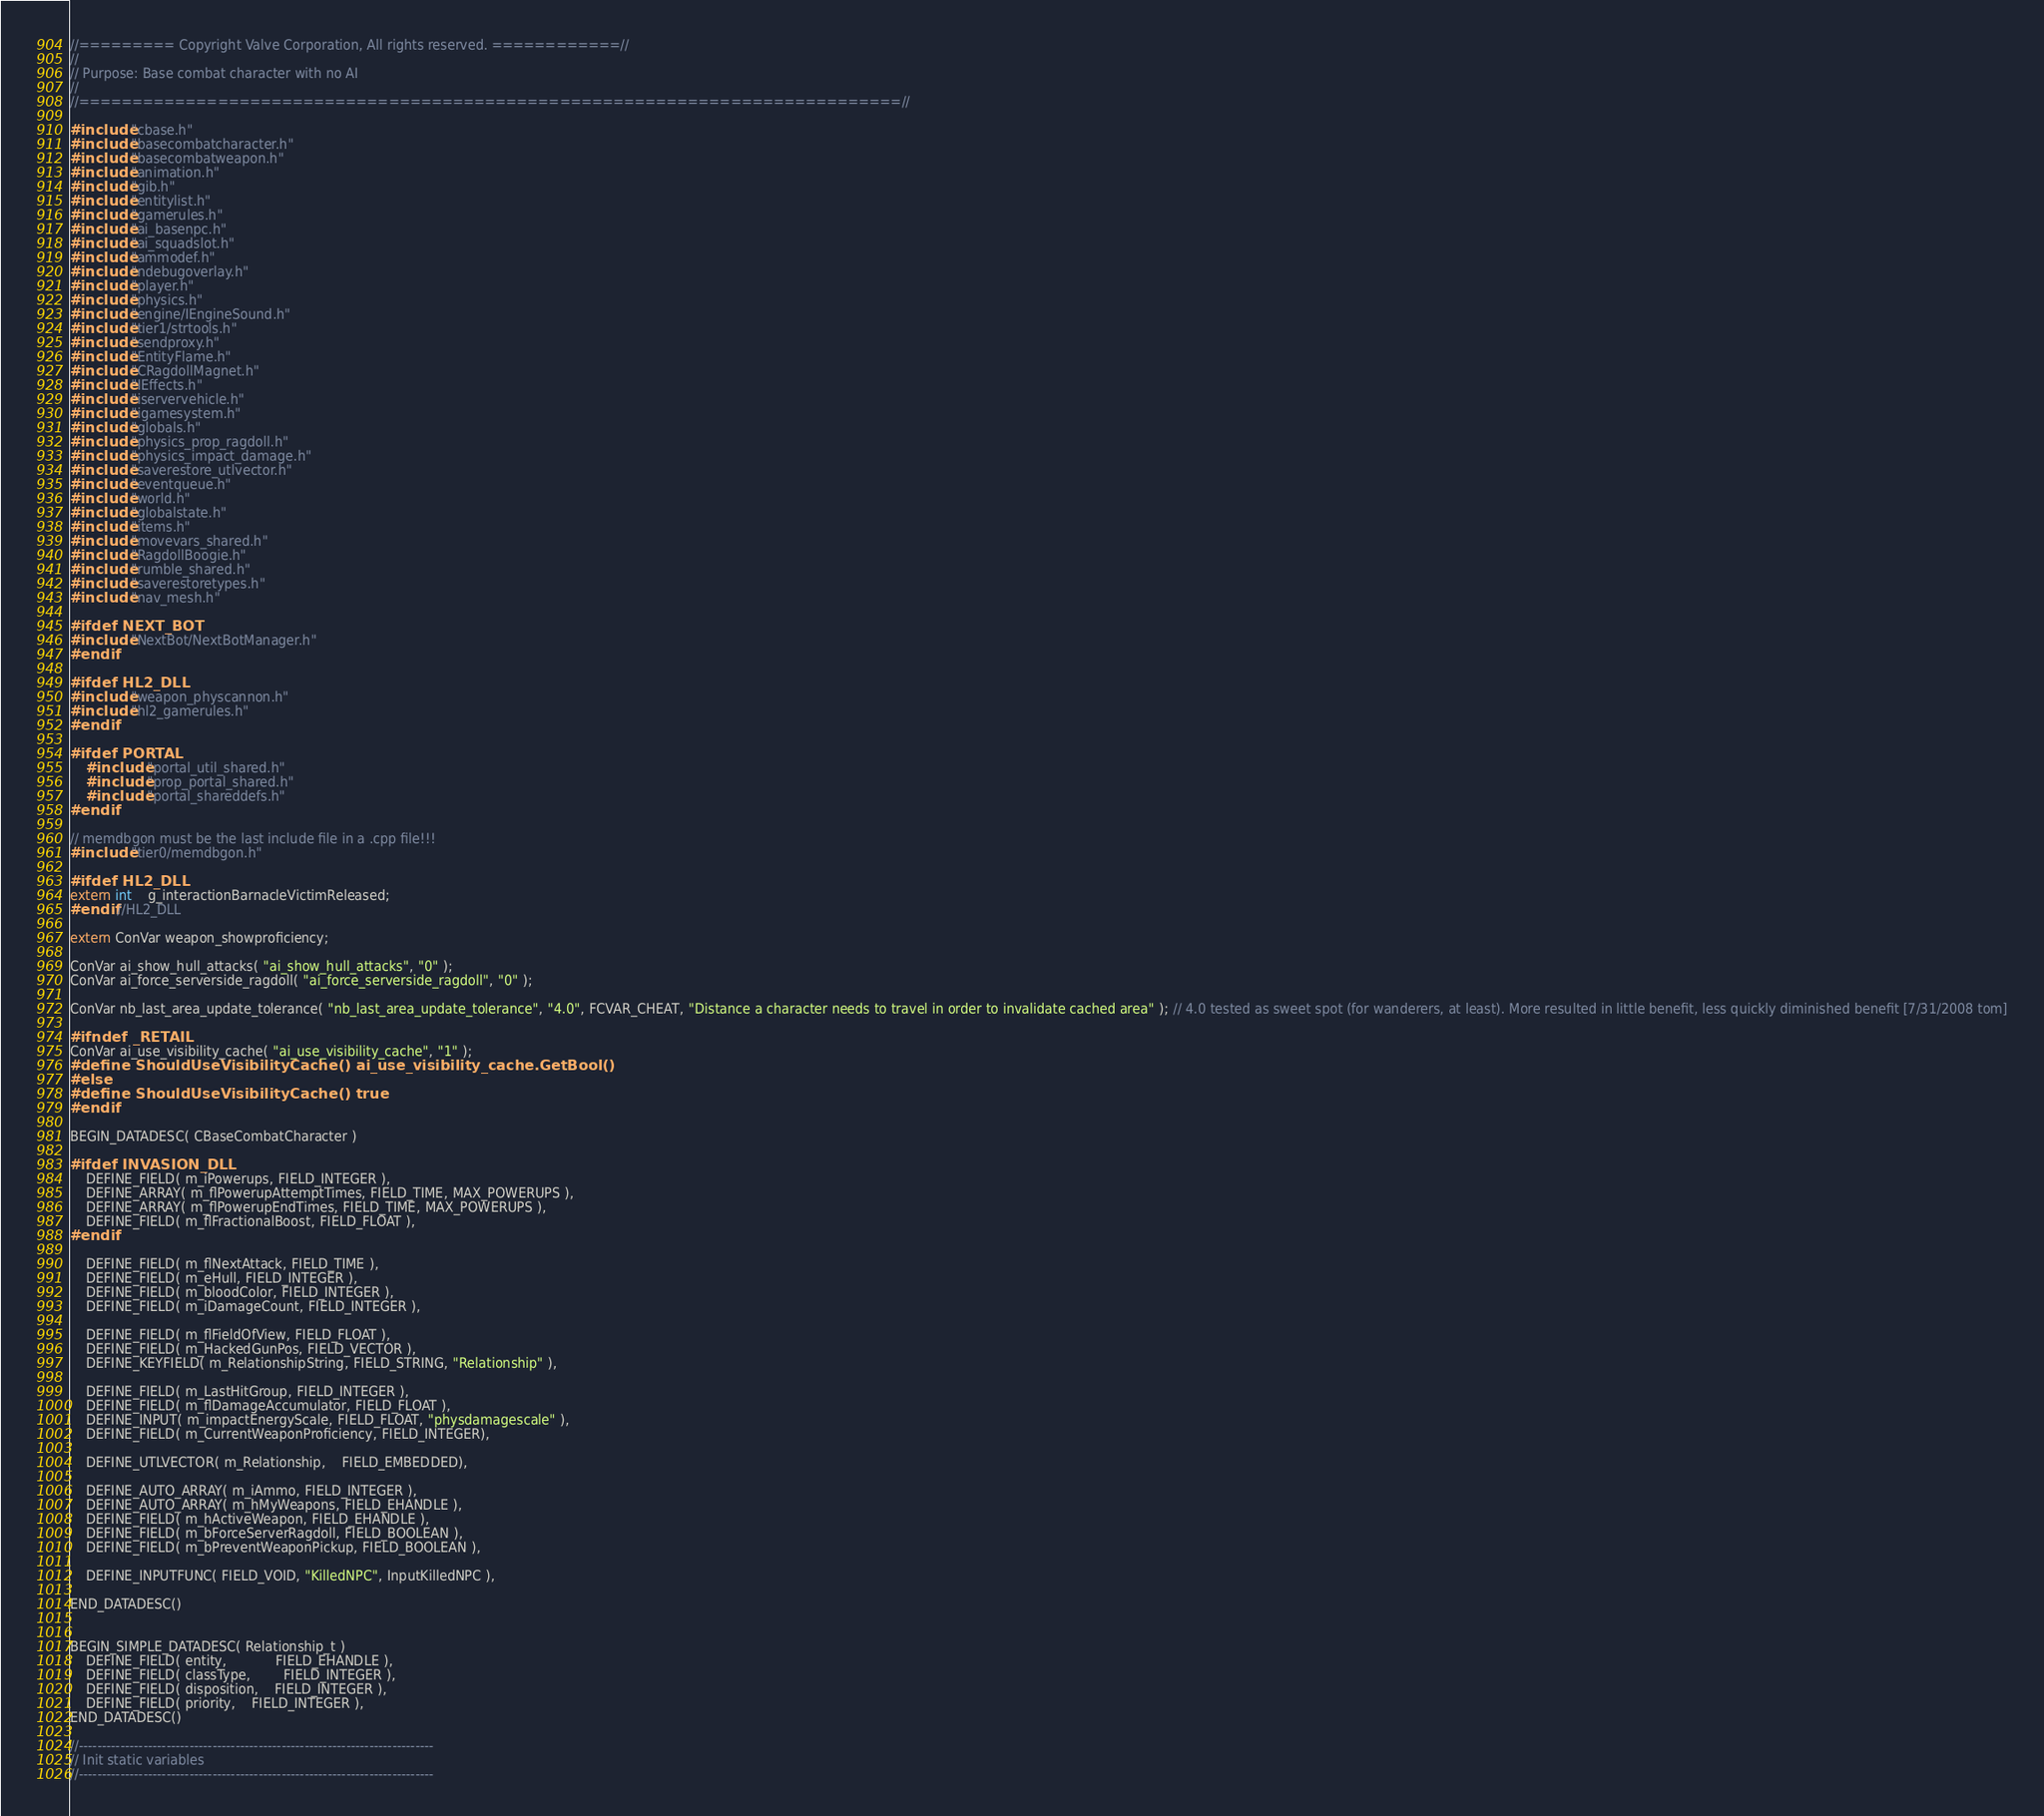Convert code to text. <code><loc_0><loc_0><loc_500><loc_500><_C++_>//========= Copyright Valve Corporation, All rights reserved. ============//
//
// Purpose: Base combat character with no AI
//
//=============================================================================//

#include "cbase.h"
#include "basecombatcharacter.h"
#include "basecombatweapon.h"
#include "animation.h"
#include "gib.h"
#include "entitylist.h"
#include "gamerules.h"
#include "ai_basenpc.h"
#include "ai_squadslot.h"
#include "ammodef.h"
#include "ndebugoverlay.h"
#include "player.h"
#include "physics.h"
#include "engine/IEngineSound.h"
#include "tier1/strtools.h"
#include "sendproxy.h"
#include "EntityFlame.h"
#include "CRagdollMagnet.h"
#include "IEffects.h"
#include "iservervehicle.h"
#include "igamesystem.h"
#include "globals.h"
#include "physics_prop_ragdoll.h"
#include "physics_impact_damage.h"
#include "saverestore_utlvector.h"
#include "eventqueue.h"
#include "world.h"
#include "globalstate.h"
#include "items.h"
#include "movevars_shared.h"
#include "RagdollBoogie.h"
#include "rumble_shared.h"
#include "saverestoretypes.h"
#include "nav_mesh.h"

#ifdef NEXT_BOT
#include "NextBot/NextBotManager.h"
#endif

#ifdef HL2_DLL
#include "weapon_physcannon.h"
#include "hl2_gamerules.h"
#endif

#ifdef PORTAL
	#include "portal_util_shared.h"
	#include "prop_portal_shared.h"
	#include "portal_shareddefs.h"
#endif

// memdbgon must be the last include file in a .cpp file!!!
#include "tier0/memdbgon.h"

#ifdef HL2_DLL
extern int	g_interactionBarnacleVictimReleased;
#endif //HL2_DLL

extern ConVar weapon_showproficiency;

ConVar ai_show_hull_attacks( "ai_show_hull_attacks", "0" );
ConVar ai_force_serverside_ragdoll( "ai_force_serverside_ragdoll", "0" );

ConVar nb_last_area_update_tolerance( "nb_last_area_update_tolerance", "4.0", FCVAR_CHEAT, "Distance a character needs to travel in order to invalidate cached area" ); // 4.0 tested as sweet spot (for wanderers, at least). More resulted in little benefit, less quickly diminished benefit [7/31/2008 tom]

#ifndef _RETAIL
ConVar ai_use_visibility_cache( "ai_use_visibility_cache", "1" );
#define ShouldUseVisibilityCache() ai_use_visibility_cache.GetBool()
#else
#define ShouldUseVisibilityCache() true
#endif

BEGIN_DATADESC( CBaseCombatCharacter )

#ifdef INVASION_DLL
	DEFINE_FIELD( m_iPowerups, FIELD_INTEGER ),
	DEFINE_ARRAY( m_flPowerupAttemptTimes, FIELD_TIME, MAX_POWERUPS ),
	DEFINE_ARRAY( m_flPowerupEndTimes, FIELD_TIME, MAX_POWERUPS ),
	DEFINE_FIELD( m_flFractionalBoost, FIELD_FLOAT ),
#endif

	DEFINE_FIELD( m_flNextAttack, FIELD_TIME ),
	DEFINE_FIELD( m_eHull, FIELD_INTEGER ),
	DEFINE_FIELD( m_bloodColor, FIELD_INTEGER ),
	DEFINE_FIELD( m_iDamageCount, FIELD_INTEGER ),
	
	DEFINE_FIELD( m_flFieldOfView, FIELD_FLOAT ),
	DEFINE_FIELD( m_HackedGunPos, FIELD_VECTOR ),
	DEFINE_KEYFIELD( m_RelationshipString, FIELD_STRING, "Relationship" ),

	DEFINE_FIELD( m_LastHitGroup, FIELD_INTEGER ),
	DEFINE_FIELD( m_flDamageAccumulator, FIELD_FLOAT ),
	DEFINE_INPUT( m_impactEnergyScale, FIELD_FLOAT, "physdamagescale" ),
	DEFINE_FIELD( m_CurrentWeaponProficiency, FIELD_INTEGER),

	DEFINE_UTLVECTOR( m_Relationship,	FIELD_EMBEDDED),

	DEFINE_AUTO_ARRAY( m_iAmmo, FIELD_INTEGER ),
	DEFINE_AUTO_ARRAY( m_hMyWeapons, FIELD_EHANDLE ),
	DEFINE_FIELD( m_hActiveWeapon, FIELD_EHANDLE ),
	DEFINE_FIELD( m_bForceServerRagdoll, FIELD_BOOLEAN ),
	DEFINE_FIELD( m_bPreventWeaponPickup, FIELD_BOOLEAN ),

	DEFINE_INPUTFUNC( FIELD_VOID, "KilledNPC", InputKilledNPC ),

END_DATADESC()


BEGIN_SIMPLE_DATADESC( Relationship_t )
	DEFINE_FIELD( entity,			FIELD_EHANDLE ),
	DEFINE_FIELD( classType,		FIELD_INTEGER ),
	DEFINE_FIELD( disposition,	FIELD_INTEGER ),
	DEFINE_FIELD( priority,	FIELD_INTEGER ),
END_DATADESC()

//-----------------------------------------------------------------------------
// Init static variables
//-----------------------------------------------------------------------------</code> 